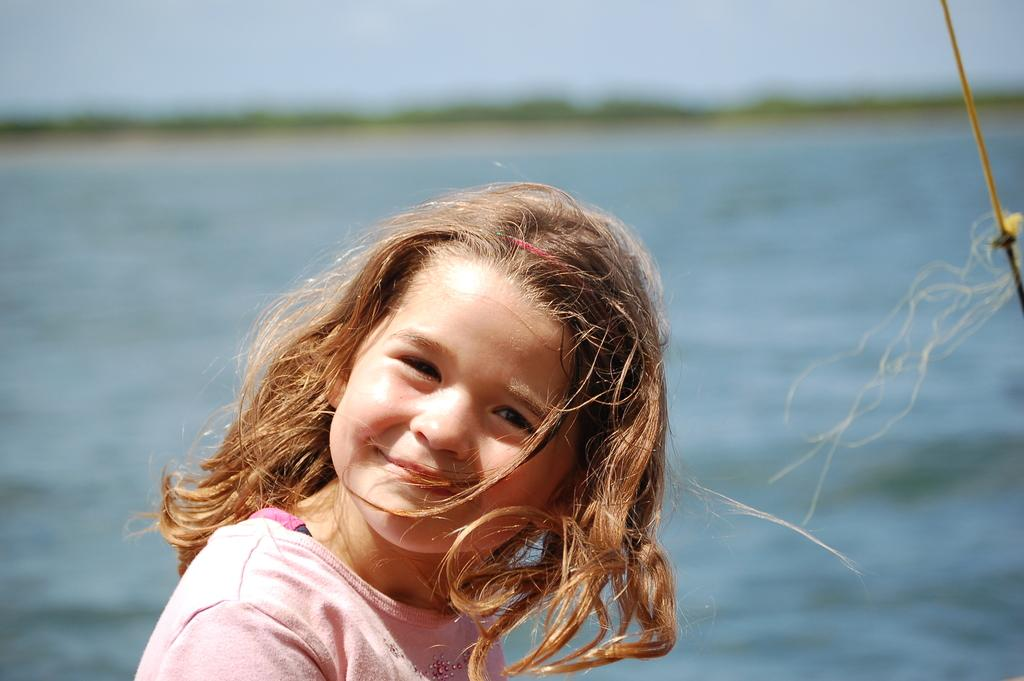Who is the main subject in the image? There is a girl in the image. What is the girl wearing? The girl is wearing a pink T-shirt. What is the girl's expression in the image? The girl is smiling. What can be seen in the background of the image? There is a river visible in the background of the image. How is the background of the image depicted? The background is blurred. What type of pie is the girl holding in the image? There is no pie present in the image; the girl is not holding anything. 